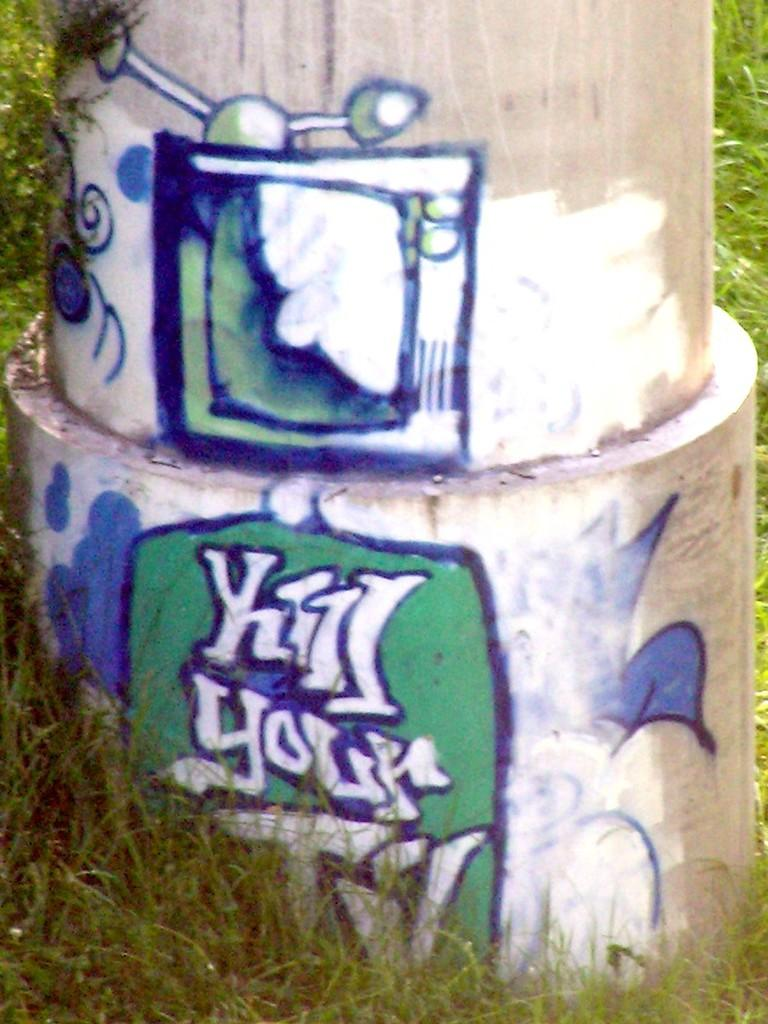What is the main structure visible in the image? There is a pillar in the image. What is depicted on the pillar? There is a painting on the pillar. What type of natural environment is visible at the bottom of the image? There is grass at the bottom of the image. What type of music is the band playing in the image? There is no band present in the image, so it is not possible to determine what type of music they might be playing. 